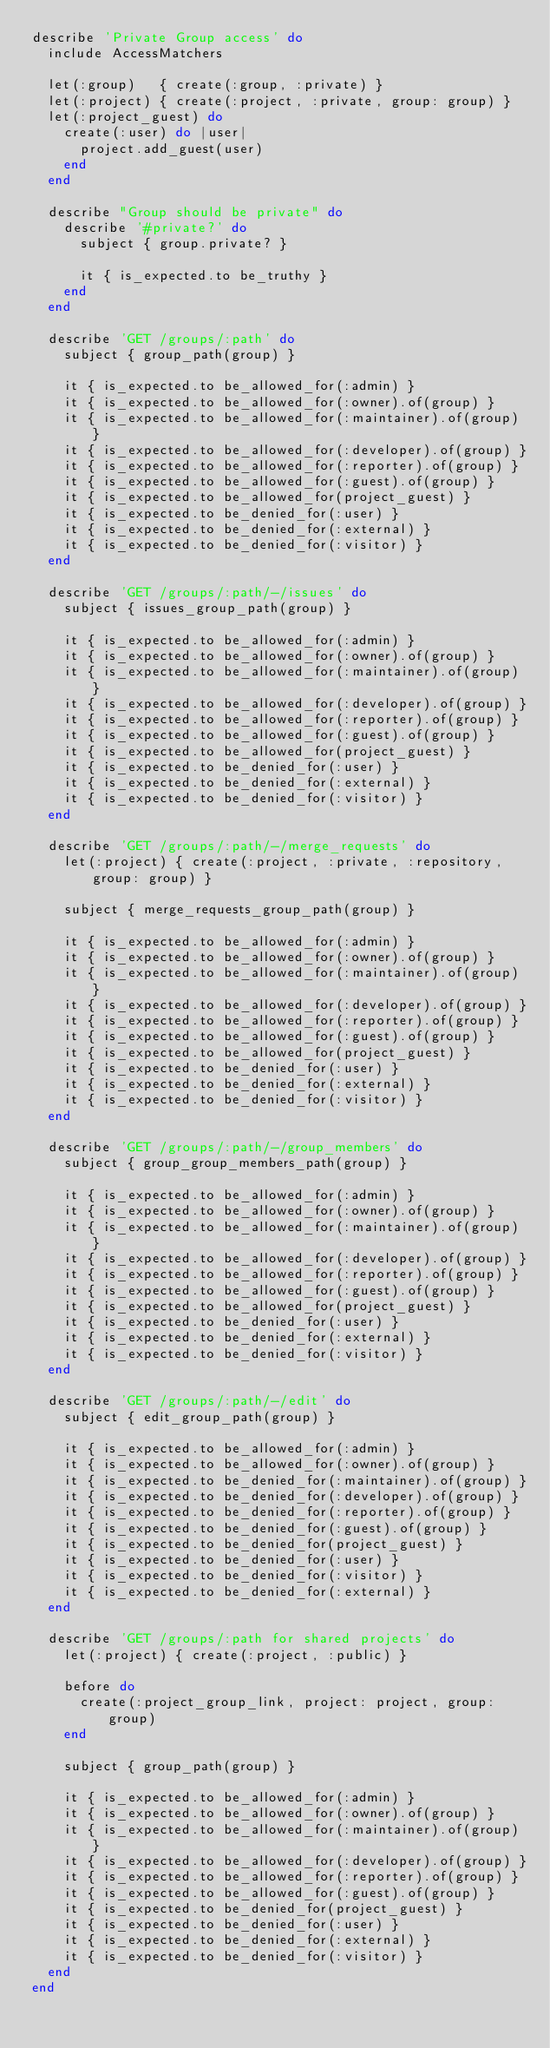<code> <loc_0><loc_0><loc_500><loc_500><_Ruby_>describe 'Private Group access' do
  include AccessMatchers

  let(:group)   { create(:group, :private) }
  let(:project) { create(:project, :private, group: group) }
  let(:project_guest) do
    create(:user) do |user|
      project.add_guest(user)
    end
  end

  describe "Group should be private" do
    describe '#private?' do
      subject { group.private? }

      it { is_expected.to be_truthy }
    end
  end

  describe 'GET /groups/:path' do
    subject { group_path(group) }

    it { is_expected.to be_allowed_for(:admin) }
    it { is_expected.to be_allowed_for(:owner).of(group) }
    it { is_expected.to be_allowed_for(:maintainer).of(group) }
    it { is_expected.to be_allowed_for(:developer).of(group) }
    it { is_expected.to be_allowed_for(:reporter).of(group) }
    it { is_expected.to be_allowed_for(:guest).of(group) }
    it { is_expected.to be_allowed_for(project_guest) }
    it { is_expected.to be_denied_for(:user) }
    it { is_expected.to be_denied_for(:external) }
    it { is_expected.to be_denied_for(:visitor) }
  end

  describe 'GET /groups/:path/-/issues' do
    subject { issues_group_path(group) }

    it { is_expected.to be_allowed_for(:admin) }
    it { is_expected.to be_allowed_for(:owner).of(group) }
    it { is_expected.to be_allowed_for(:maintainer).of(group) }
    it { is_expected.to be_allowed_for(:developer).of(group) }
    it { is_expected.to be_allowed_for(:reporter).of(group) }
    it { is_expected.to be_allowed_for(:guest).of(group) }
    it { is_expected.to be_allowed_for(project_guest) }
    it { is_expected.to be_denied_for(:user) }
    it { is_expected.to be_denied_for(:external) }
    it { is_expected.to be_denied_for(:visitor) }
  end

  describe 'GET /groups/:path/-/merge_requests' do
    let(:project) { create(:project, :private, :repository, group: group) }

    subject { merge_requests_group_path(group) }

    it { is_expected.to be_allowed_for(:admin) }
    it { is_expected.to be_allowed_for(:owner).of(group) }
    it { is_expected.to be_allowed_for(:maintainer).of(group) }
    it { is_expected.to be_allowed_for(:developer).of(group) }
    it { is_expected.to be_allowed_for(:reporter).of(group) }
    it { is_expected.to be_allowed_for(:guest).of(group) }
    it { is_expected.to be_allowed_for(project_guest) }
    it { is_expected.to be_denied_for(:user) }
    it { is_expected.to be_denied_for(:external) }
    it { is_expected.to be_denied_for(:visitor) }
  end

  describe 'GET /groups/:path/-/group_members' do
    subject { group_group_members_path(group) }

    it { is_expected.to be_allowed_for(:admin) }
    it { is_expected.to be_allowed_for(:owner).of(group) }
    it { is_expected.to be_allowed_for(:maintainer).of(group) }
    it { is_expected.to be_allowed_for(:developer).of(group) }
    it { is_expected.to be_allowed_for(:reporter).of(group) }
    it { is_expected.to be_allowed_for(:guest).of(group) }
    it { is_expected.to be_allowed_for(project_guest) }
    it { is_expected.to be_denied_for(:user) }
    it { is_expected.to be_denied_for(:external) }
    it { is_expected.to be_denied_for(:visitor) }
  end

  describe 'GET /groups/:path/-/edit' do
    subject { edit_group_path(group) }

    it { is_expected.to be_allowed_for(:admin) }
    it { is_expected.to be_allowed_for(:owner).of(group) }
    it { is_expected.to be_denied_for(:maintainer).of(group) }
    it { is_expected.to be_denied_for(:developer).of(group) }
    it { is_expected.to be_denied_for(:reporter).of(group) }
    it { is_expected.to be_denied_for(:guest).of(group) }
    it { is_expected.to be_denied_for(project_guest) }
    it { is_expected.to be_denied_for(:user) }
    it { is_expected.to be_denied_for(:visitor) }
    it { is_expected.to be_denied_for(:external) }
  end

  describe 'GET /groups/:path for shared projects' do
    let(:project) { create(:project, :public) }

    before do
      create(:project_group_link, project: project, group: group)
    end

    subject { group_path(group) }

    it { is_expected.to be_allowed_for(:admin) }
    it { is_expected.to be_allowed_for(:owner).of(group) }
    it { is_expected.to be_allowed_for(:maintainer).of(group) }
    it { is_expected.to be_allowed_for(:developer).of(group) }
    it { is_expected.to be_allowed_for(:reporter).of(group) }
    it { is_expected.to be_allowed_for(:guest).of(group) }
    it { is_expected.to be_denied_for(project_guest) }
    it { is_expected.to be_denied_for(:user) }
    it { is_expected.to be_denied_for(:external) }
    it { is_expected.to be_denied_for(:visitor) }
  end
end
</code> 